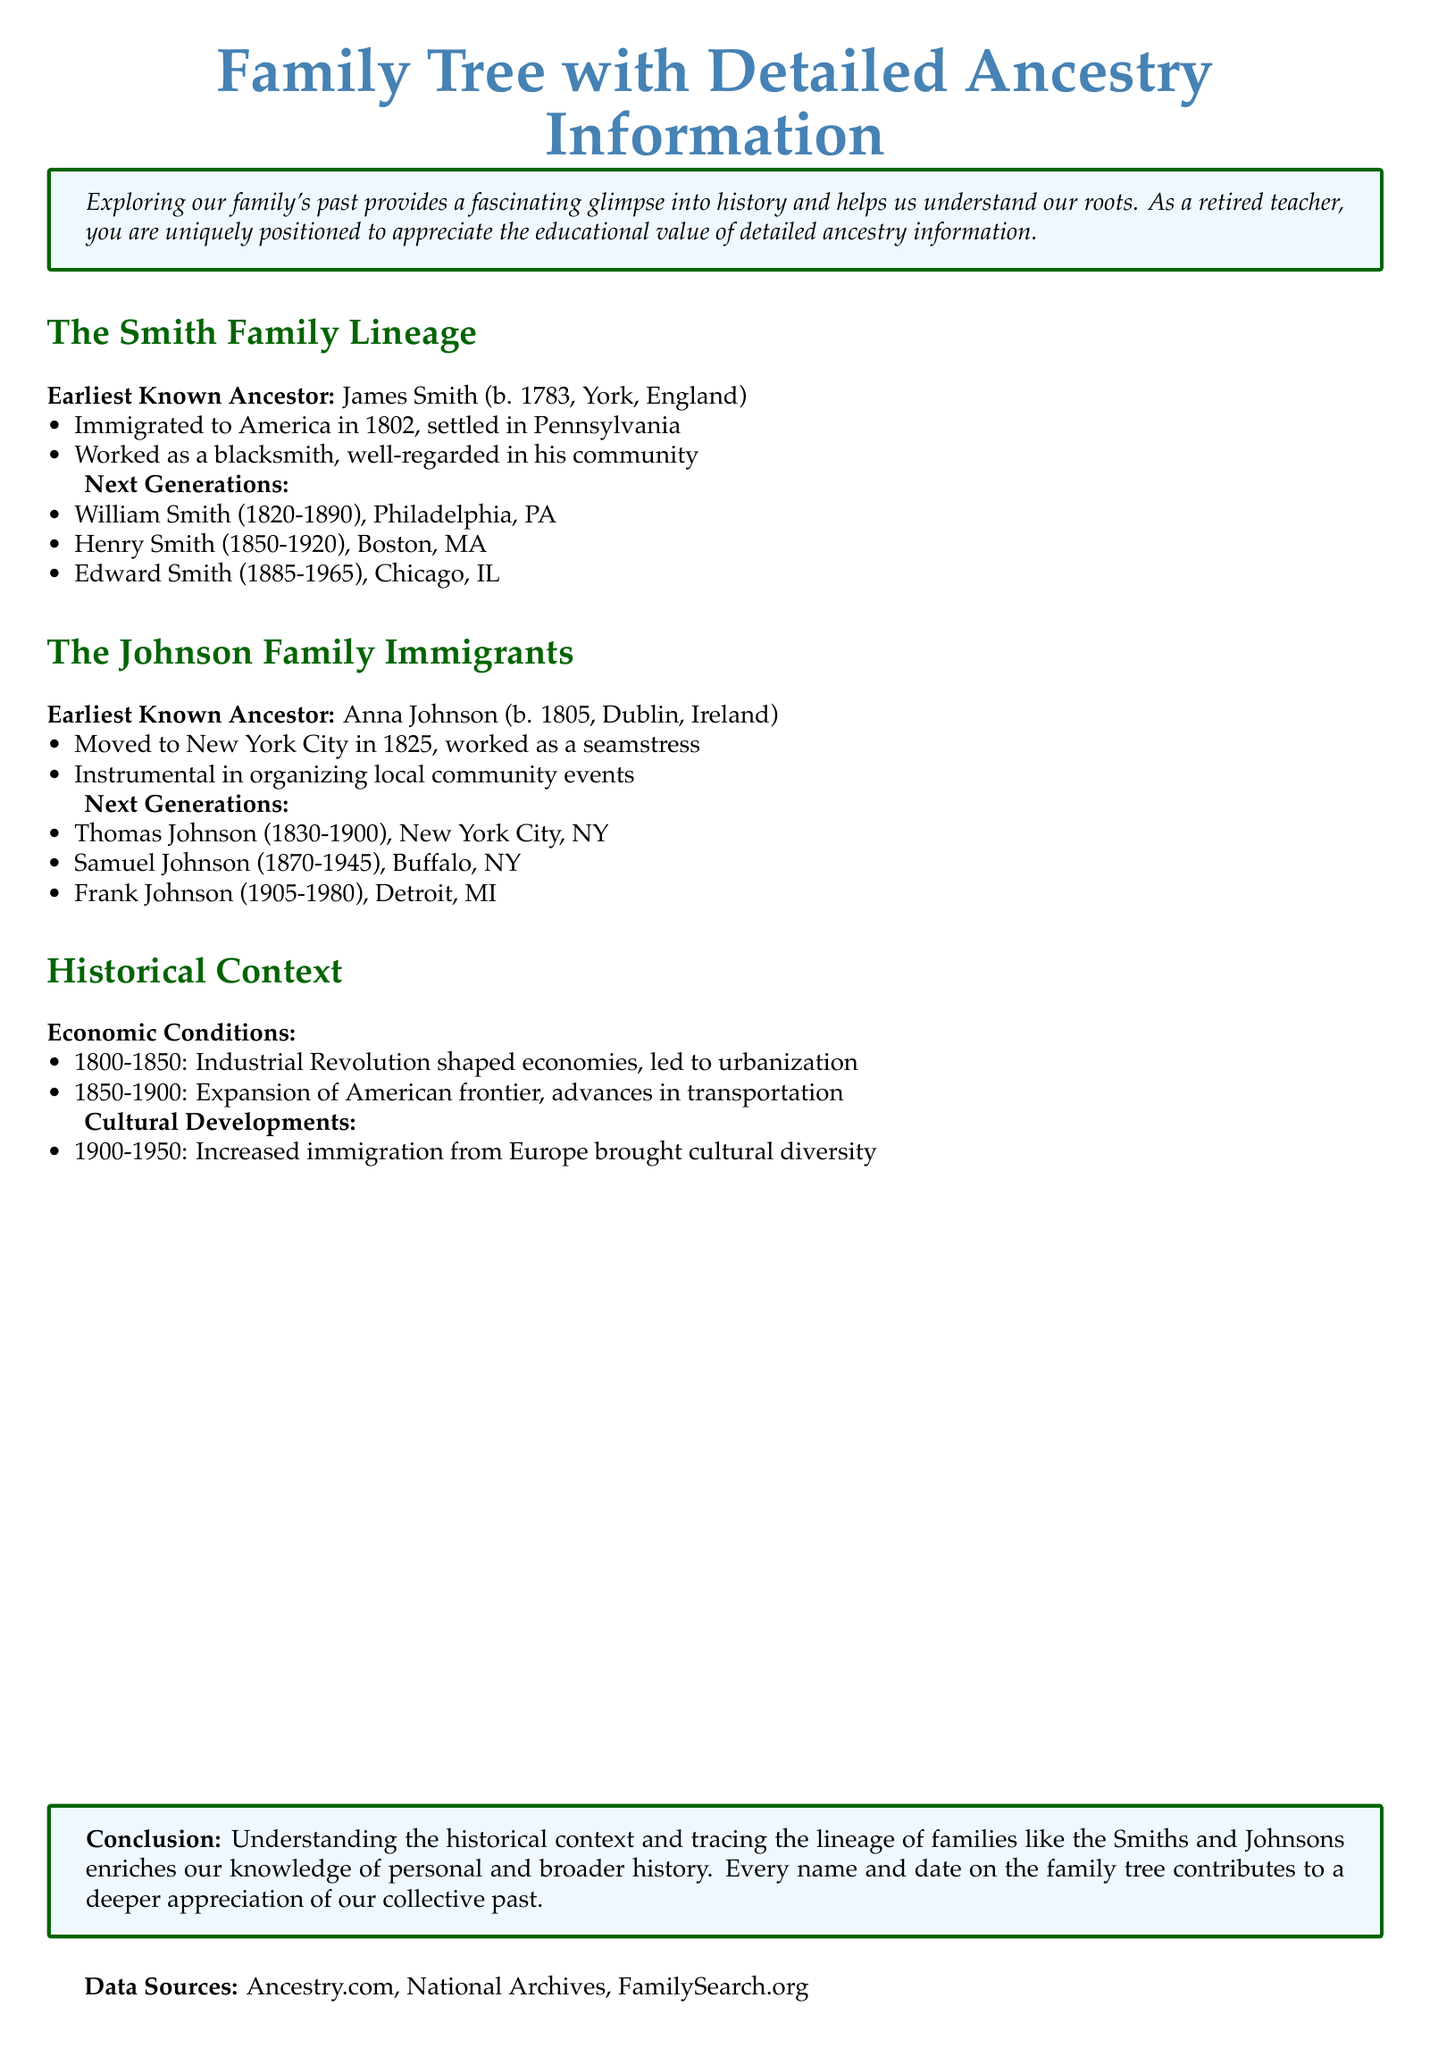What is the name of the earliest known ancestor in the Smith family? The earliest known ancestor in the Smith family is James Smith, as stated in the document.
Answer: James Smith In what year did Anna Johnson immigrate to New York City? Anna Johnson moved to New York City in 1825, which is provided in her section of the document.
Answer: 1825 Who was a blacksmith in the Smith family lineage? The document states that James Smith worked as a blacksmith, making this the specific reference for the question.
Answer: James Smith What profession did Anna Johnson hold? The document indicates that Anna Johnson worked as a seamstress, which directly answers the question.
Answer: Seamstress Which generation does Edward Smith belong to? The document lists Edward Smith in the context of the next generations, specifically indicating his place.
Answer: Next Generation What was the time frame of the Industrial Revolution mentioned in the historical context? The document specifies that the Industrial Revolution shaped economies from 1800 to 1850.
Answer: 1800-1850 How many generations are listed for the Johnson family? The document provides three names of subsequent generations for the Johnson family, leading to this conclusion.
Answer: Three What is the total number of families detailed in this document? The document outlines two family lineages, the Smiths and the Johnsons.
Answer: Two What type of events did Anna Johnson organize? It is mentioned in the document that Anna Johnson was instrumental in organizing local community events, providing a clear answer.
Answer: Community events 